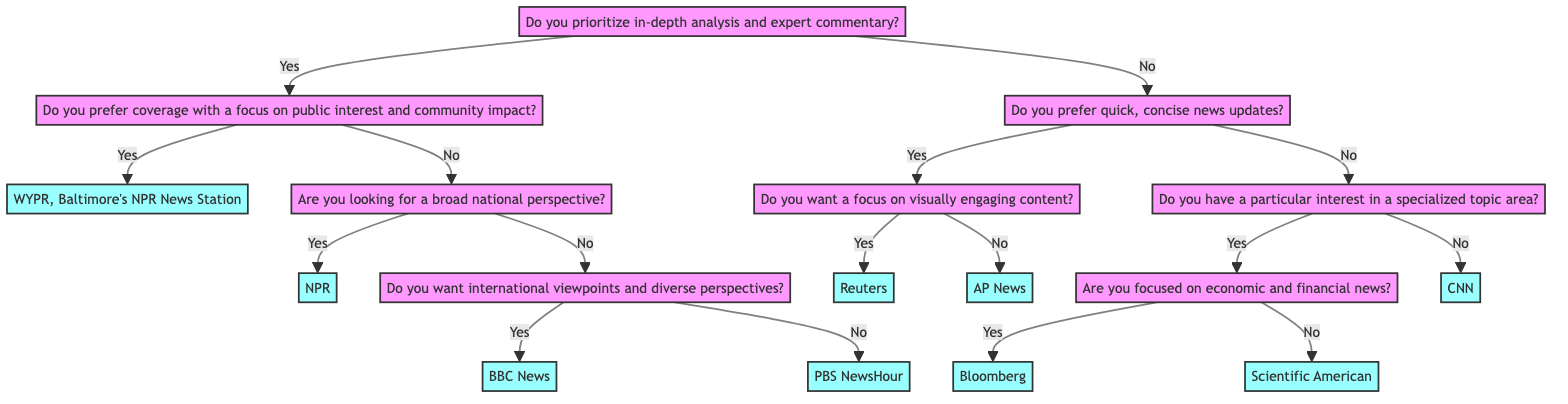What is the first question in the decision tree? The first question in the decision tree is about prioritizing in-depth analysis and expert commentary. It is the root node from which all subsequent branches stem.
Answer: Do you prioritize in-depth analysis and expert commentary? How many outlets are there in total in the decision tree? The decision tree contains a total of 9 outlets, which are the final nodes after answering all the questions. Each outlet is unique and represents a different political news coverage option.
Answer: 9 If someone answers "No" to the first question, which question do they encounter next? If the answer is "No" to the first question regarding prioritizing in-depth analysis, the next question they encounter is about preferring quick, concise news updates, leading them through a different branch of the decision tree.
Answer: Do you prefer quick, concise news updates? What outlet is suggested if the answer to the question about public interest is "Yes"? If someone prefers coverage with a focus on public interest and community impact, the outlet suggested is WYPR, Baltimore's NPR News Station, as indicated in the corresponding branch of the tree.
Answer: WYPR, Baltimore's NPR News Station What is the last outlet to be suggested in the decision tree? The last outlet suggested in the decision tree, after navigating through all the questions and scenarios presented, is CNN, which is at the end of the respective path.
Answer: CNN Which outlet is recommended for those focused on economic and financial news? Those interested in economic and financial news will be directed to Bloomberg, as per the specific branch that follows the question about having a particular interest in specialized topics.
Answer: Bloomberg What happens if a person prefers coverage without visual content? If an individual answers "No" to wanting a focus on visually engaging content, they will be directed to AP News, indicating a preference for concise news updates without visual emphasis.
Answer: AP News If someone is looking for international viewpoints but not national perspectives, which outlet will they be directed to? If a person is specifically looking for international viewpoints and answers "Yes" to that question while opting out of national perspectives, they will be directed to BBC News as their preferred outlet.
Answer: BBC News 